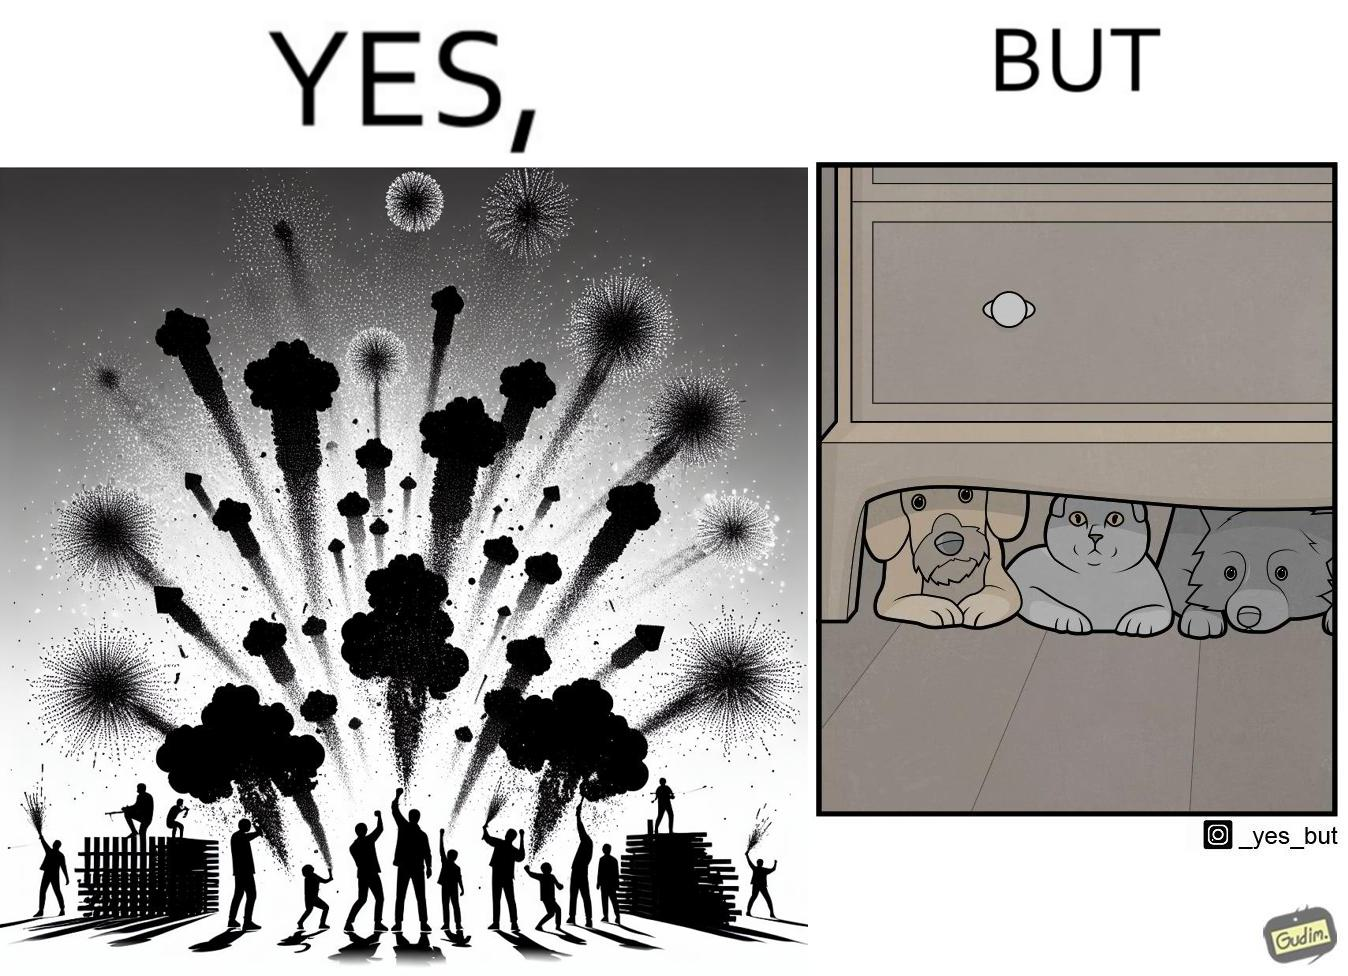Explain the humor or irony in this image. The image is satirical because while firecrackers in the sky look pretty, not everyone likes them. Animals are very scared of the firecrackers. 